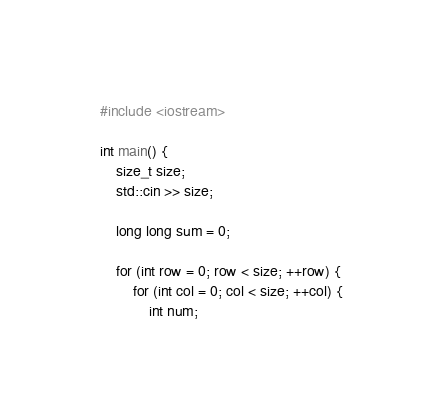<code> <loc_0><loc_0><loc_500><loc_500><_C++_>#include <iostream>

int main() {
    size_t size;
    std::cin >> size;

    long long sum = 0;

    for (int row = 0; row < size; ++row) {
        for (int col = 0; col < size; ++col) {
            int num;</code> 